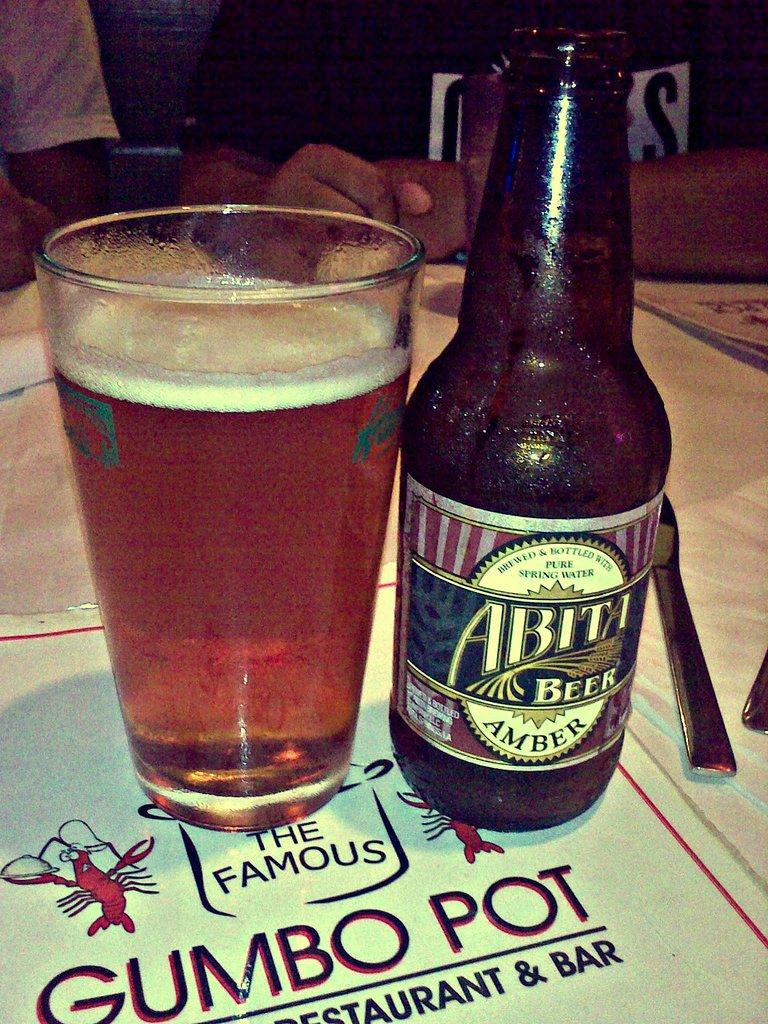<image>
Offer a succinct explanation of the picture presented. A bottle of Abiti Beer next to a full glass of presumably the same drink. 